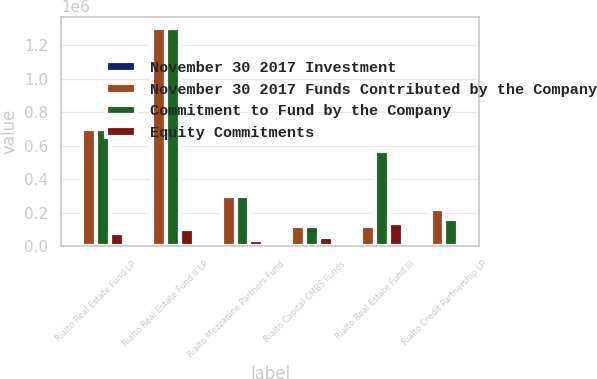<chart> <loc_0><loc_0><loc_500><loc_500><stacked_bar_chart><ecel><fcel>Rialto Real Estate Fund LP<fcel>Rialto Real Estate Fund II LP<fcel>Rialto Mezzanine Partners Fund<fcel>Rialto Capital CMBS Funds<fcel>Rialto Real Estate Fund III<fcel>Rialto Credit Partnership LP<nl><fcel>November 30 2017 Investment<fcel>2010<fcel>2012<fcel>2013<fcel>2014<fcel>2015<fcel>2016<nl><fcel>November 30 2017 Funds Contributed by the Company<fcel>700006<fcel>1.305e+06<fcel>300000<fcel>119174<fcel>119174<fcel>220000<nl><fcel>Commitment to Fund by the Company<fcel>700006<fcel>1.305e+06<fcel>300000<fcel>119174<fcel>569482<fcel>159886<nl><fcel>Equity Commitments<fcel>75000<fcel>100000<fcel>33799<fcel>52474<fcel>140000<fcel>19999<nl></chart> 